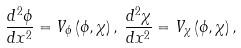<formula> <loc_0><loc_0><loc_500><loc_500>\frac { d ^ { 2 } \phi } { d x ^ { 2 } } = V _ { \phi } \left ( \phi , \chi \right ) , \, \frac { d ^ { 2 } \chi } { d x ^ { 2 } } = V _ { \chi } \left ( \phi , \chi \right ) ,</formula> 